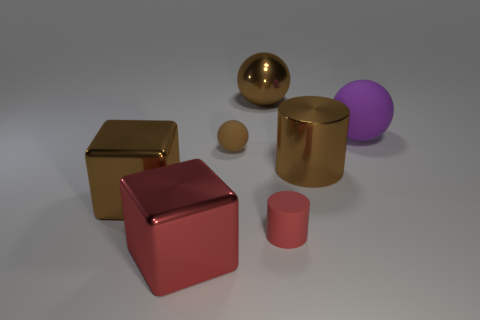Can you tell me about the way light interacts with the different objects in the scene? Certainly, the scene displays varying interactions of light across different objects. The metallic objects, with their shiny surfaces, create distinct specular highlights and reflect light brightly, while the sphere and smaller cylinder, which seem rubbery, absorb more light, causing them to have softer highlights and a less reflective finish. 